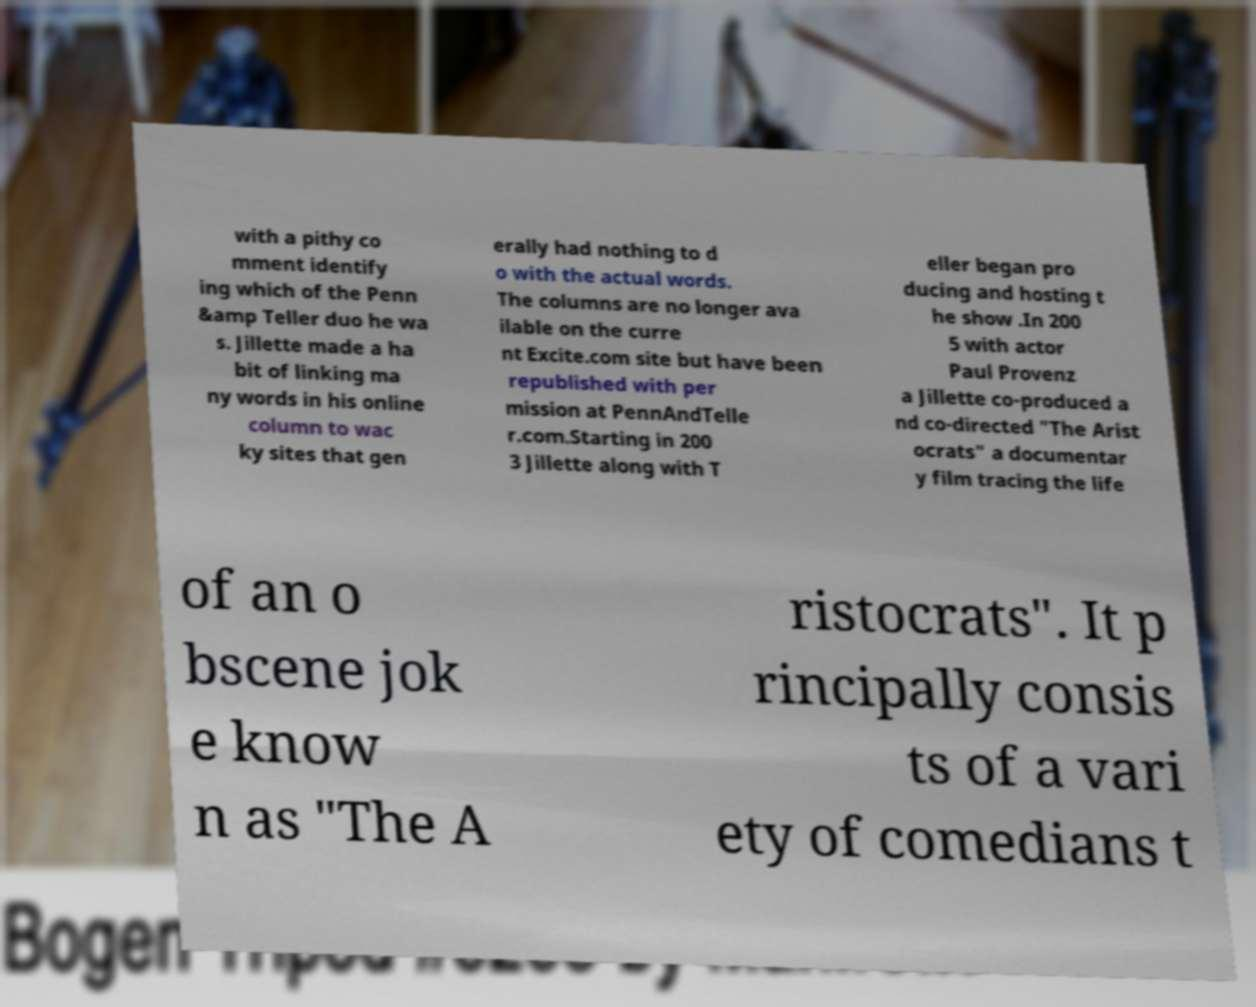Could you assist in decoding the text presented in this image and type it out clearly? with a pithy co mment identify ing which of the Penn &amp Teller duo he wa s. Jillette made a ha bit of linking ma ny words in his online column to wac ky sites that gen erally had nothing to d o with the actual words. The columns are no longer ava ilable on the curre nt Excite.com site but have been republished with per mission at PennAndTelle r.com.Starting in 200 3 Jillette along with T eller began pro ducing and hosting t he show .In 200 5 with actor Paul Provenz a Jillette co-produced a nd co-directed "The Arist ocrats" a documentar y film tracing the life of an o bscene jok e know n as "The A ristocrats". It p rincipally consis ts of a vari ety of comedians t 